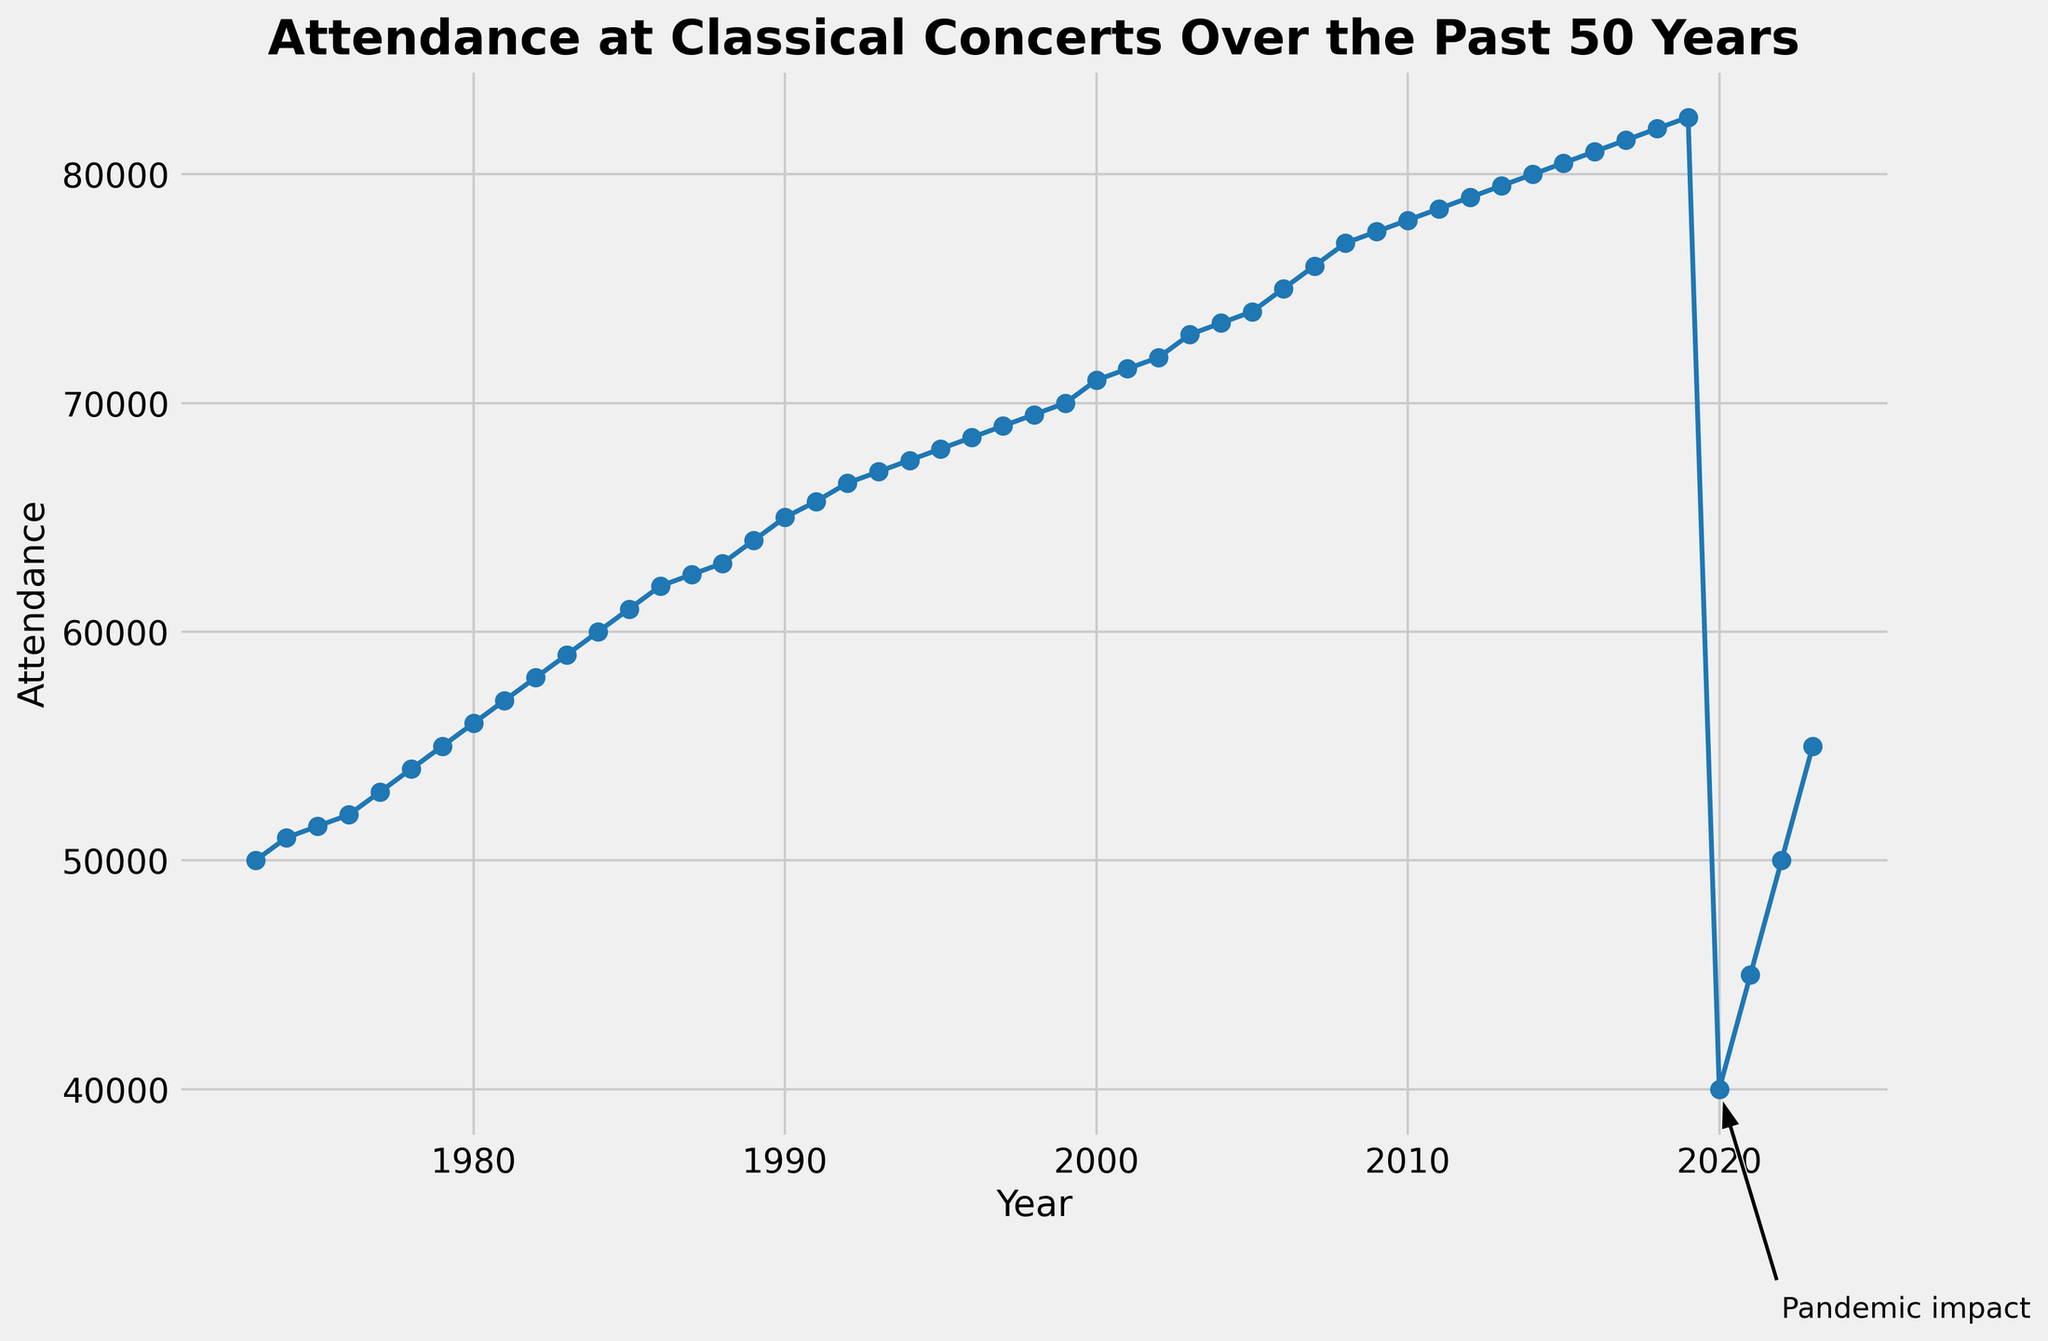What's the average attendance over the first decade (1973-1982)? First, sum the attendance values from 1973 to 1982, which gives us 500,000. Then, divide by the number of years, which is 10. So, the average attendance is 500,000 / 10 = 50,000.
Answer: 50,000 In which years did attendance first reach 65,000 and 70,000, respectively? We look at the data points on the line plot to find when the attendance first reaches 65,000 and 70,000. Attendance reaches 65,000 in 1990 and 70,000 in 1999.
Answer: 1990, 1999 How much did attendance decrease from 2019 to 2020? The attendance in 2019 was 82,500, and in 2020 it was 40,000. Subtract the two values: 82,500 - 40,000 = 42,500. Therefore, attendance decreased by 42,500.
Answer: 42,500 What was the maximum attendance before the pandemic impact annotation? To find the maximum attendance before the pandemic impact annotation, look at the highest point on the line graph before 2020. The maximum attendance was in 2019 at 82,500.
Answer: 82,500 How did attendance change from 2021 to 2023 and by how much? Attendance in 2021 was 45,000 and in 2023 it was 55,000. The change is 55,000 - 45,000 = 10,000. Attendance increased by 10,000.
Answer: 10,000 What visual cue indicates the years with significant events? The years with significant events are marked with text annotations along the plotted line.
Answer: Text annotations Identify the year with the steepest drop in attendance. How much did it drop? The year 2020 shows the steepest drop in attendance, with a decrease from 82,500 in 2019 to 40,000 in 2020, which is a drop of 42,500.
Answer: 2020, 42,500 How many years did it take for attendance to recover to 55,000 after the pandemic? Attendance dropped significantly in 2020 to 40,000. It recovered to 55,000 by 2023. The recovery period is 2023 - 2020 = 3 years.
Answer: 3 years 